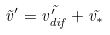Convert formula to latex. <formula><loc_0><loc_0><loc_500><loc_500>\vec { v } ^ { \prime } = \vec { v _ { d i f } ^ { \prime } } + \vec { v _ { * } }</formula> 